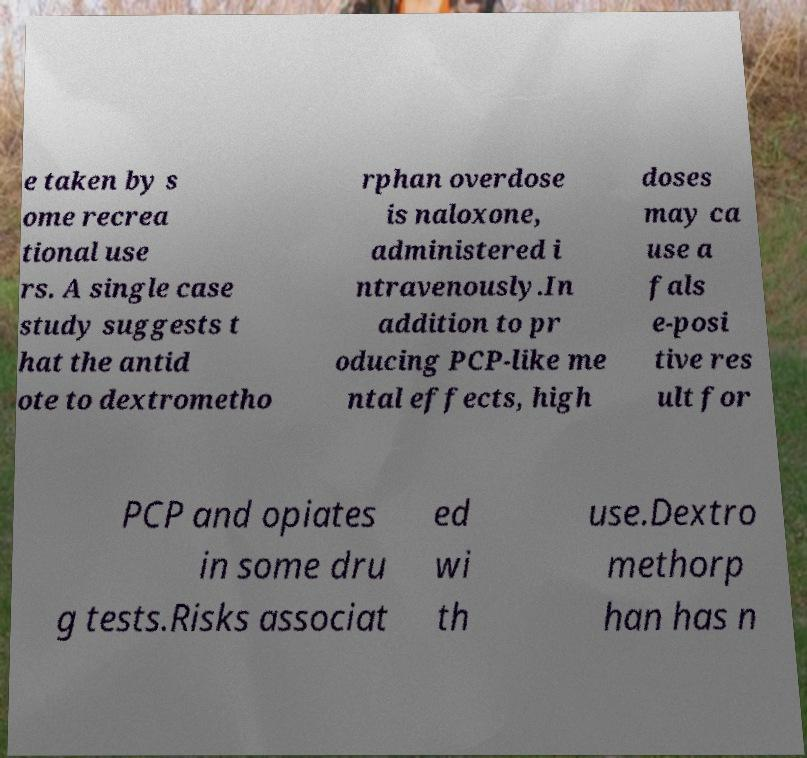There's text embedded in this image that I need extracted. Can you transcribe it verbatim? e taken by s ome recrea tional use rs. A single case study suggests t hat the antid ote to dextrometho rphan overdose is naloxone, administered i ntravenously.In addition to pr oducing PCP-like me ntal effects, high doses may ca use a fals e-posi tive res ult for PCP and opiates in some dru g tests.Risks associat ed wi th use.Dextro methorp han has n 